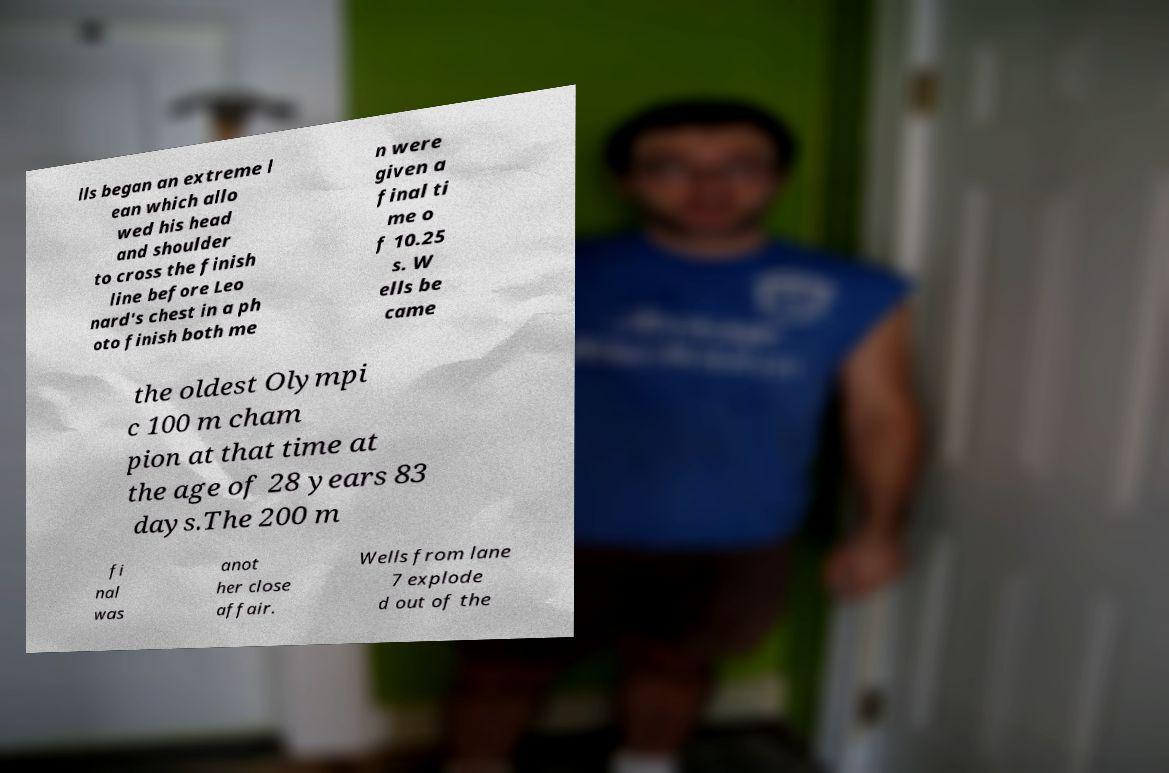Please identify and transcribe the text found in this image. lls began an extreme l ean which allo wed his head and shoulder to cross the finish line before Leo nard's chest in a ph oto finish both me n were given a final ti me o f 10.25 s. W ells be came the oldest Olympi c 100 m cham pion at that time at the age of 28 years 83 days.The 200 m fi nal was anot her close affair. Wells from lane 7 explode d out of the 